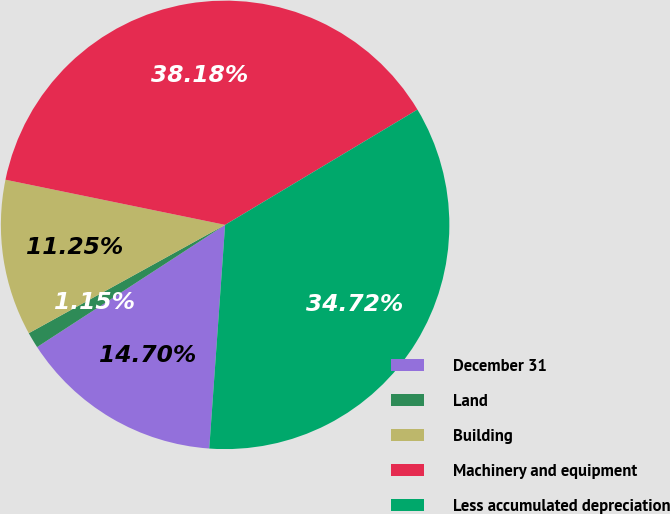Convert chart to OTSL. <chart><loc_0><loc_0><loc_500><loc_500><pie_chart><fcel>December 31<fcel>Land<fcel>Building<fcel>Machinery and equipment<fcel>Less accumulated depreciation<nl><fcel>14.7%<fcel>1.15%<fcel>11.25%<fcel>38.18%<fcel>34.72%<nl></chart> 